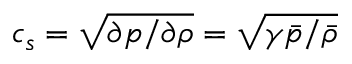Convert formula to latex. <formula><loc_0><loc_0><loc_500><loc_500>c _ { s } = \sqrt { \partial p / \partial \rho } = \sqrt { \gamma \bar { p } / \bar { \rho } }</formula> 